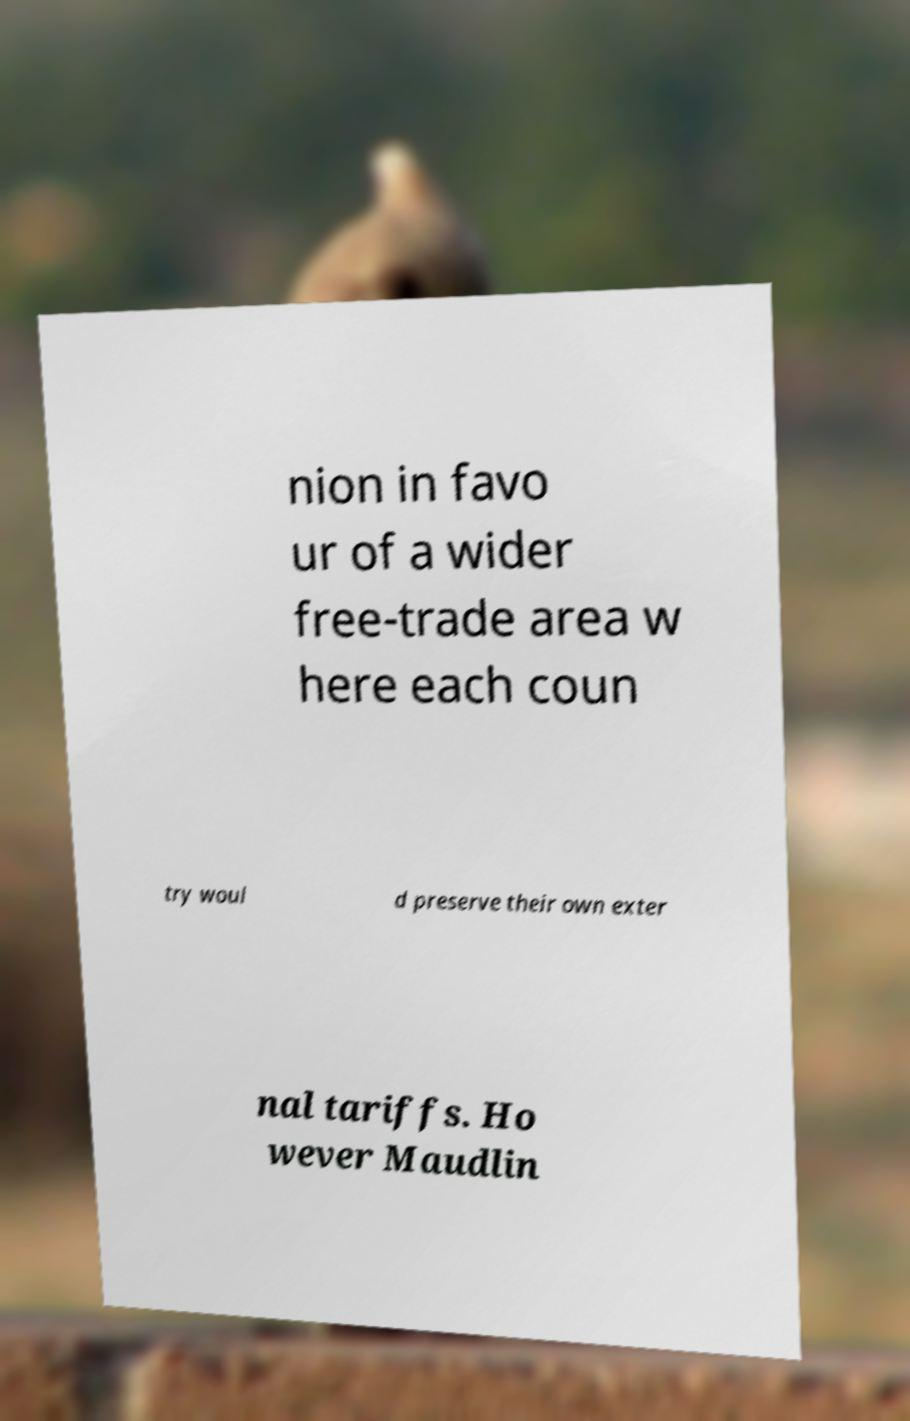Could you extract and type out the text from this image? nion in favo ur of a wider free-trade area w here each coun try woul d preserve their own exter nal tariffs. Ho wever Maudlin 